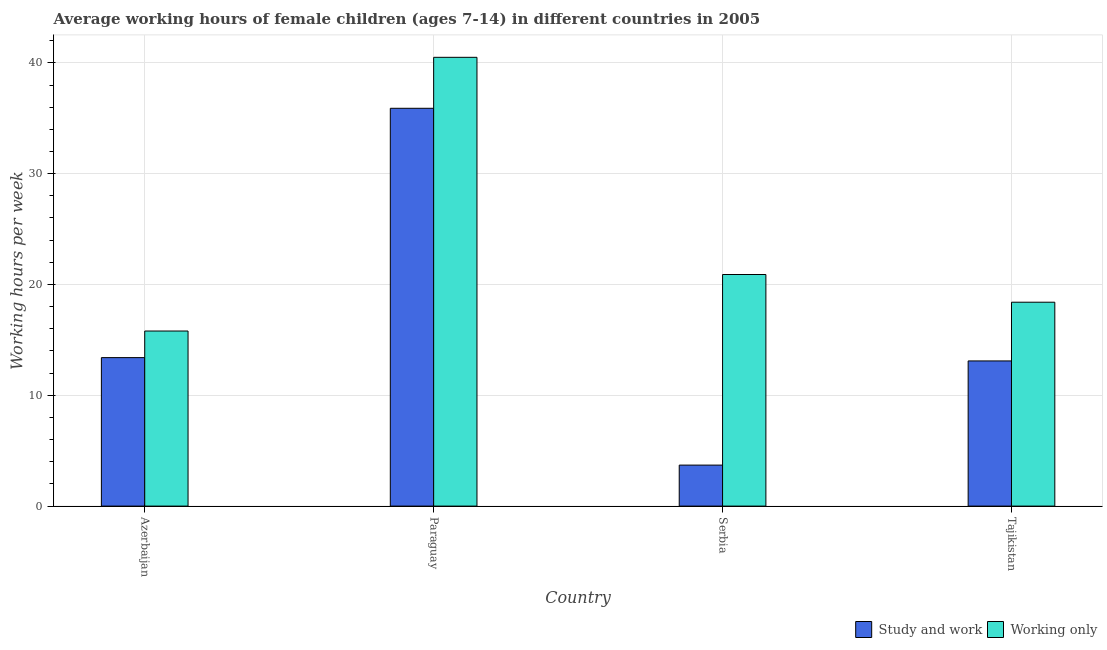How many different coloured bars are there?
Provide a succinct answer. 2. How many groups of bars are there?
Your response must be concise. 4. Are the number of bars per tick equal to the number of legend labels?
Offer a terse response. Yes. How many bars are there on the 4th tick from the left?
Offer a very short reply. 2. What is the label of the 1st group of bars from the left?
Offer a very short reply. Azerbaijan. In how many cases, is the number of bars for a given country not equal to the number of legend labels?
Provide a succinct answer. 0. What is the average working hour of children involved in only work in Serbia?
Your answer should be very brief. 20.9. Across all countries, what is the maximum average working hour of children involved in only work?
Ensure brevity in your answer.  40.5. Across all countries, what is the minimum average working hour of children involved in study and work?
Offer a terse response. 3.7. In which country was the average working hour of children involved in study and work maximum?
Your answer should be compact. Paraguay. In which country was the average working hour of children involved in only work minimum?
Keep it short and to the point. Azerbaijan. What is the total average working hour of children involved in only work in the graph?
Your answer should be compact. 95.6. What is the difference between the average working hour of children involved in only work in Paraguay and that in Serbia?
Your response must be concise. 19.6. What is the difference between the average working hour of children involved in only work in Tajikistan and the average working hour of children involved in study and work in Azerbaijan?
Make the answer very short. 5. What is the average average working hour of children involved in study and work per country?
Your answer should be very brief. 16.52. What is the difference between the average working hour of children involved in study and work and average working hour of children involved in only work in Azerbaijan?
Give a very brief answer. -2.4. What is the ratio of the average working hour of children involved in study and work in Azerbaijan to that in Paraguay?
Keep it short and to the point. 0.37. Is the difference between the average working hour of children involved in study and work in Azerbaijan and Serbia greater than the difference between the average working hour of children involved in only work in Azerbaijan and Serbia?
Offer a very short reply. Yes. What is the difference between the highest and the second highest average working hour of children involved in only work?
Offer a very short reply. 19.6. What is the difference between the highest and the lowest average working hour of children involved in only work?
Offer a terse response. 24.7. In how many countries, is the average working hour of children involved in study and work greater than the average average working hour of children involved in study and work taken over all countries?
Ensure brevity in your answer.  1. What does the 2nd bar from the left in Azerbaijan represents?
Your response must be concise. Working only. What does the 2nd bar from the right in Azerbaijan represents?
Offer a very short reply. Study and work. How many bars are there?
Keep it short and to the point. 8. Are all the bars in the graph horizontal?
Give a very brief answer. No. What is the difference between two consecutive major ticks on the Y-axis?
Your answer should be very brief. 10. Are the values on the major ticks of Y-axis written in scientific E-notation?
Your response must be concise. No. Does the graph contain any zero values?
Give a very brief answer. No. Does the graph contain grids?
Give a very brief answer. Yes. Where does the legend appear in the graph?
Your answer should be compact. Bottom right. How are the legend labels stacked?
Your response must be concise. Horizontal. What is the title of the graph?
Offer a very short reply. Average working hours of female children (ages 7-14) in different countries in 2005. What is the label or title of the X-axis?
Make the answer very short. Country. What is the label or title of the Y-axis?
Your answer should be very brief. Working hours per week. What is the Working hours per week in Study and work in Paraguay?
Offer a terse response. 35.9. What is the Working hours per week of Working only in Paraguay?
Give a very brief answer. 40.5. What is the Working hours per week of Study and work in Serbia?
Your response must be concise. 3.7. What is the Working hours per week in Working only in Serbia?
Your answer should be very brief. 20.9. Across all countries, what is the maximum Working hours per week of Study and work?
Offer a very short reply. 35.9. Across all countries, what is the maximum Working hours per week in Working only?
Offer a very short reply. 40.5. Across all countries, what is the minimum Working hours per week in Study and work?
Make the answer very short. 3.7. What is the total Working hours per week in Study and work in the graph?
Your response must be concise. 66.1. What is the total Working hours per week of Working only in the graph?
Provide a succinct answer. 95.6. What is the difference between the Working hours per week in Study and work in Azerbaijan and that in Paraguay?
Make the answer very short. -22.5. What is the difference between the Working hours per week in Working only in Azerbaijan and that in Paraguay?
Your answer should be compact. -24.7. What is the difference between the Working hours per week of Study and work in Azerbaijan and that in Tajikistan?
Your answer should be compact. 0.3. What is the difference between the Working hours per week in Study and work in Paraguay and that in Serbia?
Provide a short and direct response. 32.2. What is the difference between the Working hours per week of Working only in Paraguay and that in Serbia?
Give a very brief answer. 19.6. What is the difference between the Working hours per week in Study and work in Paraguay and that in Tajikistan?
Your response must be concise. 22.8. What is the difference between the Working hours per week in Working only in Paraguay and that in Tajikistan?
Your answer should be very brief. 22.1. What is the difference between the Working hours per week of Study and work in Serbia and that in Tajikistan?
Keep it short and to the point. -9.4. What is the difference between the Working hours per week of Working only in Serbia and that in Tajikistan?
Make the answer very short. 2.5. What is the difference between the Working hours per week in Study and work in Azerbaijan and the Working hours per week in Working only in Paraguay?
Give a very brief answer. -27.1. What is the difference between the Working hours per week in Study and work in Azerbaijan and the Working hours per week in Working only in Serbia?
Give a very brief answer. -7.5. What is the difference between the Working hours per week in Study and work in Azerbaijan and the Working hours per week in Working only in Tajikistan?
Ensure brevity in your answer.  -5. What is the difference between the Working hours per week in Study and work in Paraguay and the Working hours per week in Working only in Tajikistan?
Offer a very short reply. 17.5. What is the difference between the Working hours per week in Study and work in Serbia and the Working hours per week in Working only in Tajikistan?
Offer a very short reply. -14.7. What is the average Working hours per week in Study and work per country?
Your answer should be compact. 16.52. What is the average Working hours per week of Working only per country?
Give a very brief answer. 23.9. What is the difference between the Working hours per week of Study and work and Working hours per week of Working only in Azerbaijan?
Your response must be concise. -2.4. What is the difference between the Working hours per week in Study and work and Working hours per week in Working only in Paraguay?
Provide a succinct answer. -4.6. What is the difference between the Working hours per week in Study and work and Working hours per week in Working only in Serbia?
Ensure brevity in your answer.  -17.2. What is the ratio of the Working hours per week of Study and work in Azerbaijan to that in Paraguay?
Your answer should be very brief. 0.37. What is the ratio of the Working hours per week in Working only in Azerbaijan to that in Paraguay?
Give a very brief answer. 0.39. What is the ratio of the Working hours per week in Study and work in Azerbaijan to that in Serbia?
Offer a terse response. 3.62. What is the ratio of the Working hours per week in Working only in Azerbaijan to that in Serbia?
Offer a terse response. 0.76. What is the ratio of the Working hours per week in Study and work in Azerbaijan to that in Tajikistan?
Provide a succinct answer. 1.02. What is the ratio of the Working hours per week of Working only in Azerbaijan to that in Tajikistan?
Your response must be concise. 0.86. What is the ratio of the Working hours per week in Study and work in Paraguay to that in Serbia?
Your answer should be compact. 9.7. What is the ratio of the Working hours per week in Working only in Paraguay to that in Serbia?
Keep it short and to the point. 1.94. What is the ratio of the Working hours per week in Study and work in Paraguay to that in Tajikistan?
Your answer should be compact. 2.74. What is the ratio of the Working hours per week in Working only in Paraguay to that in Tajikistan?
Offer a terse response. 2.2. What is the ratio of the Working hours per week in Study and work in Serbia to that in Tajikistan?
Keep it short and to the point. 0.28. What is the ratio of the Working hours per week of Working only in Serbia to that in Tajikistan?
Your answer should be compact. 1.14. What is the difference between the highest and the second highest Working hours per week of Working only?
Provide a short and direct response. 19.6. What is the difference between the highest and the lowest Working hours per week of Study and work?
Keep it short and to the point. 32.2. What is the difference between the highest and the lowest Working hours per week in Working only?
Your answer should be compact. 24.7. 